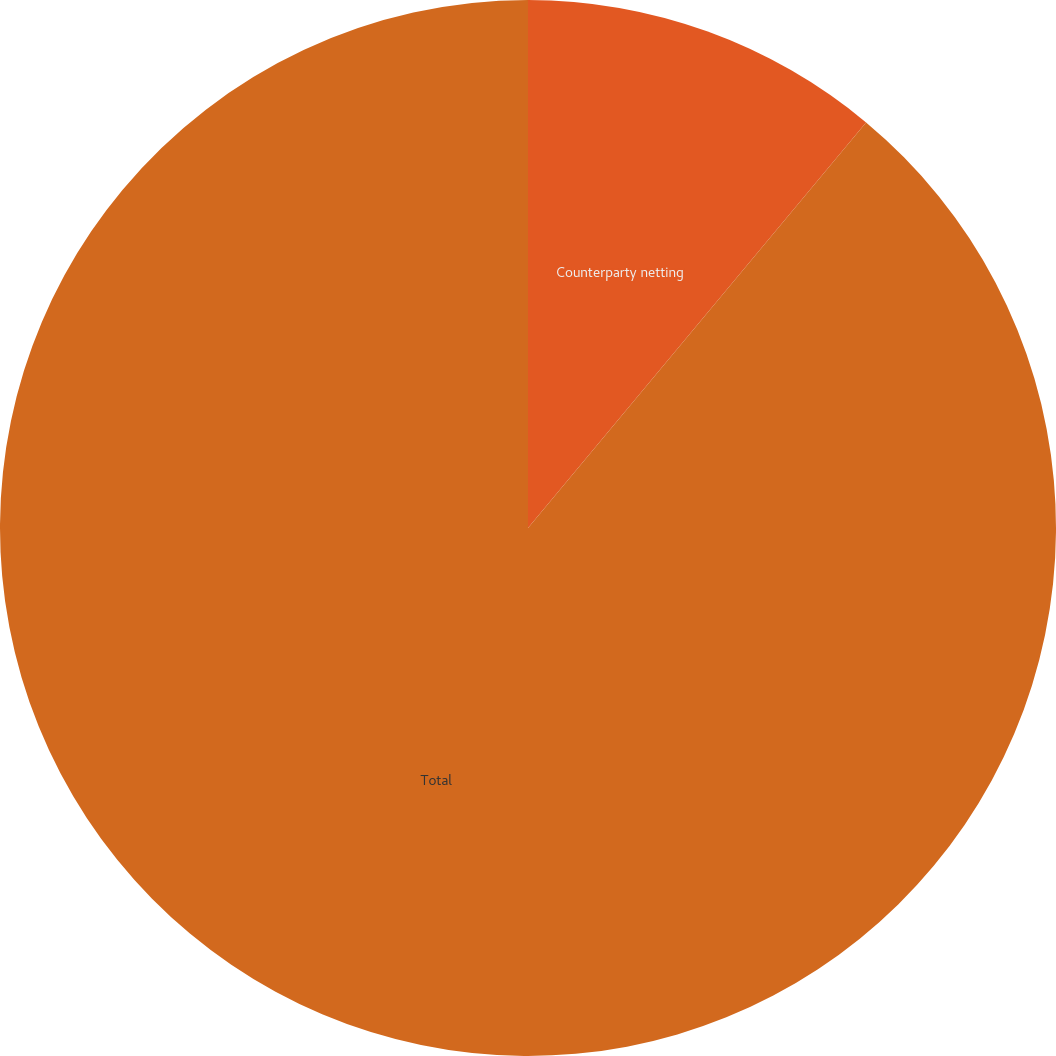Convert chart. <chart><loc_0><loc_0><loc_500><loc_500><pie_chart><fcel>Counterparty netting<fcel>Total<nl><fcel>11.06%<fcel>88.94%<nl></chart> 